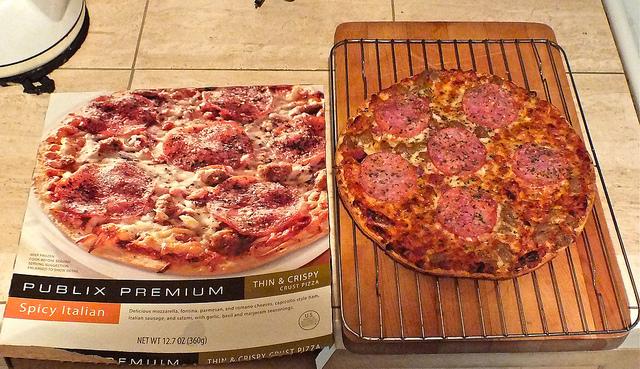What topping is on the pizza?
Concise answer only. Pepperoni. Is the cutting board clean?
Quick response, please. Yes. Does the pizza look well done?
Be succinct. Yes. What grocery store is the pizza from?
Give a very brief answer. Publix. What is the brand of the pizzas?
Be succinct. Publix. What color is the grill?
Answer briefly. Silver. 